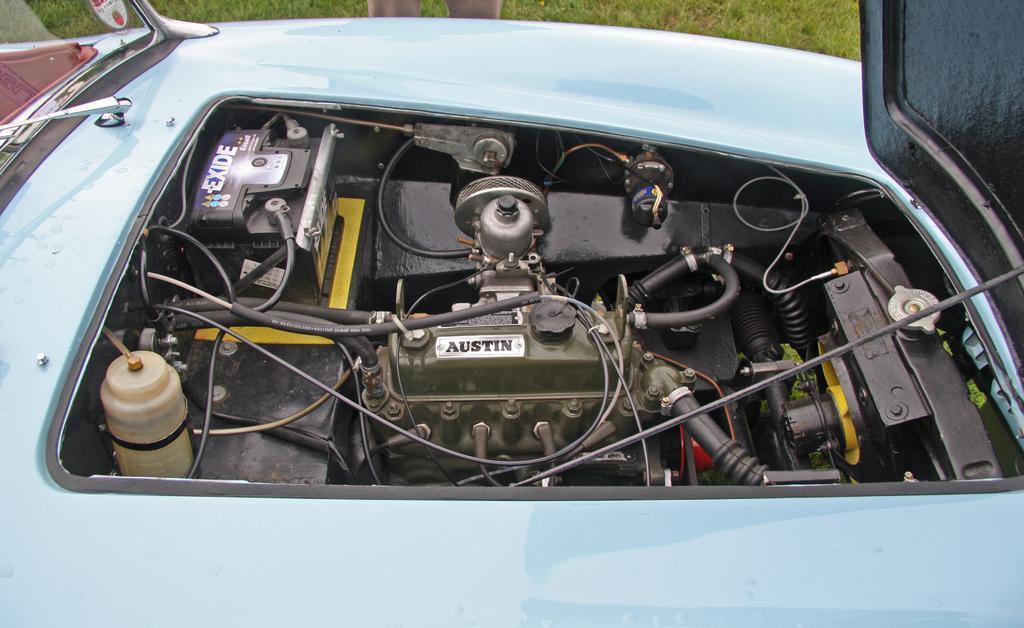In one or two sentences, can you explain what this image depicts? In this image I can see car and I can see vehicle part of the car and I can see person leg visible at the top. 